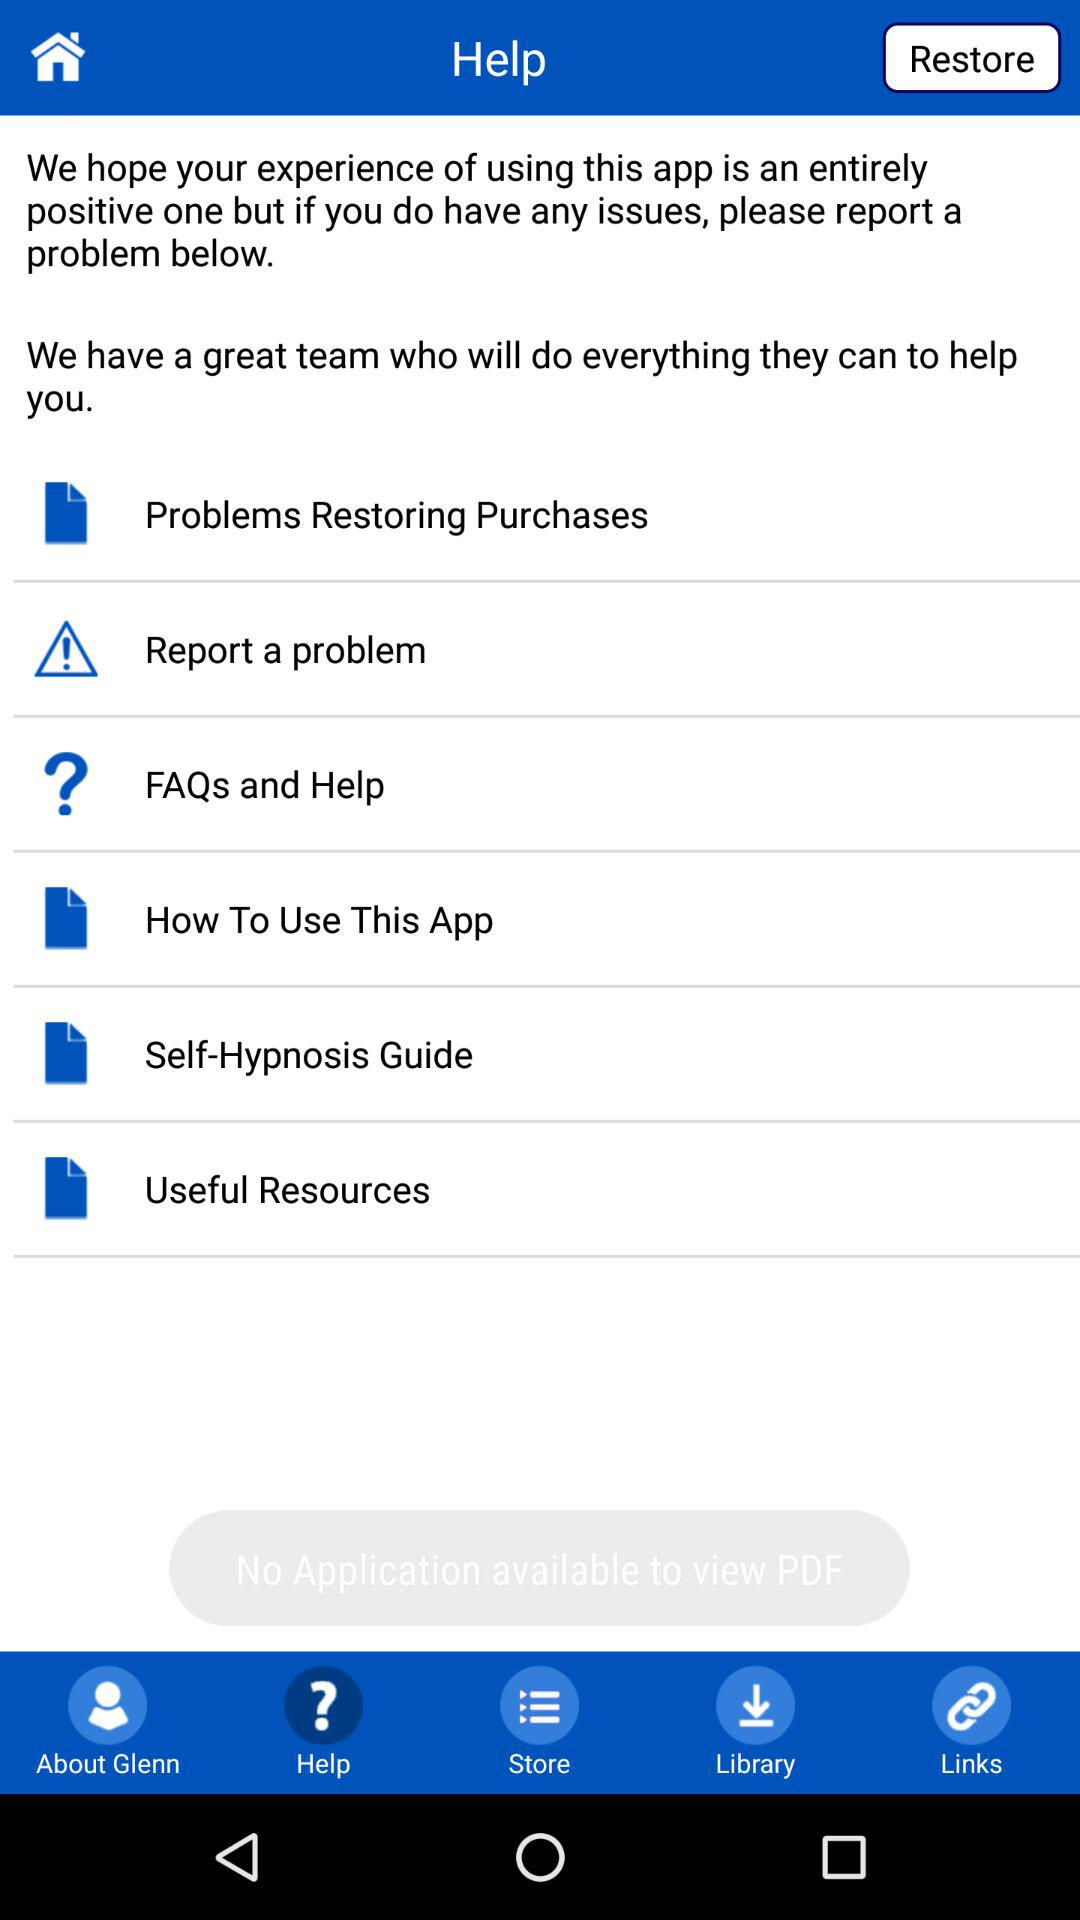Which option is selected? The option "Help" is selected. 